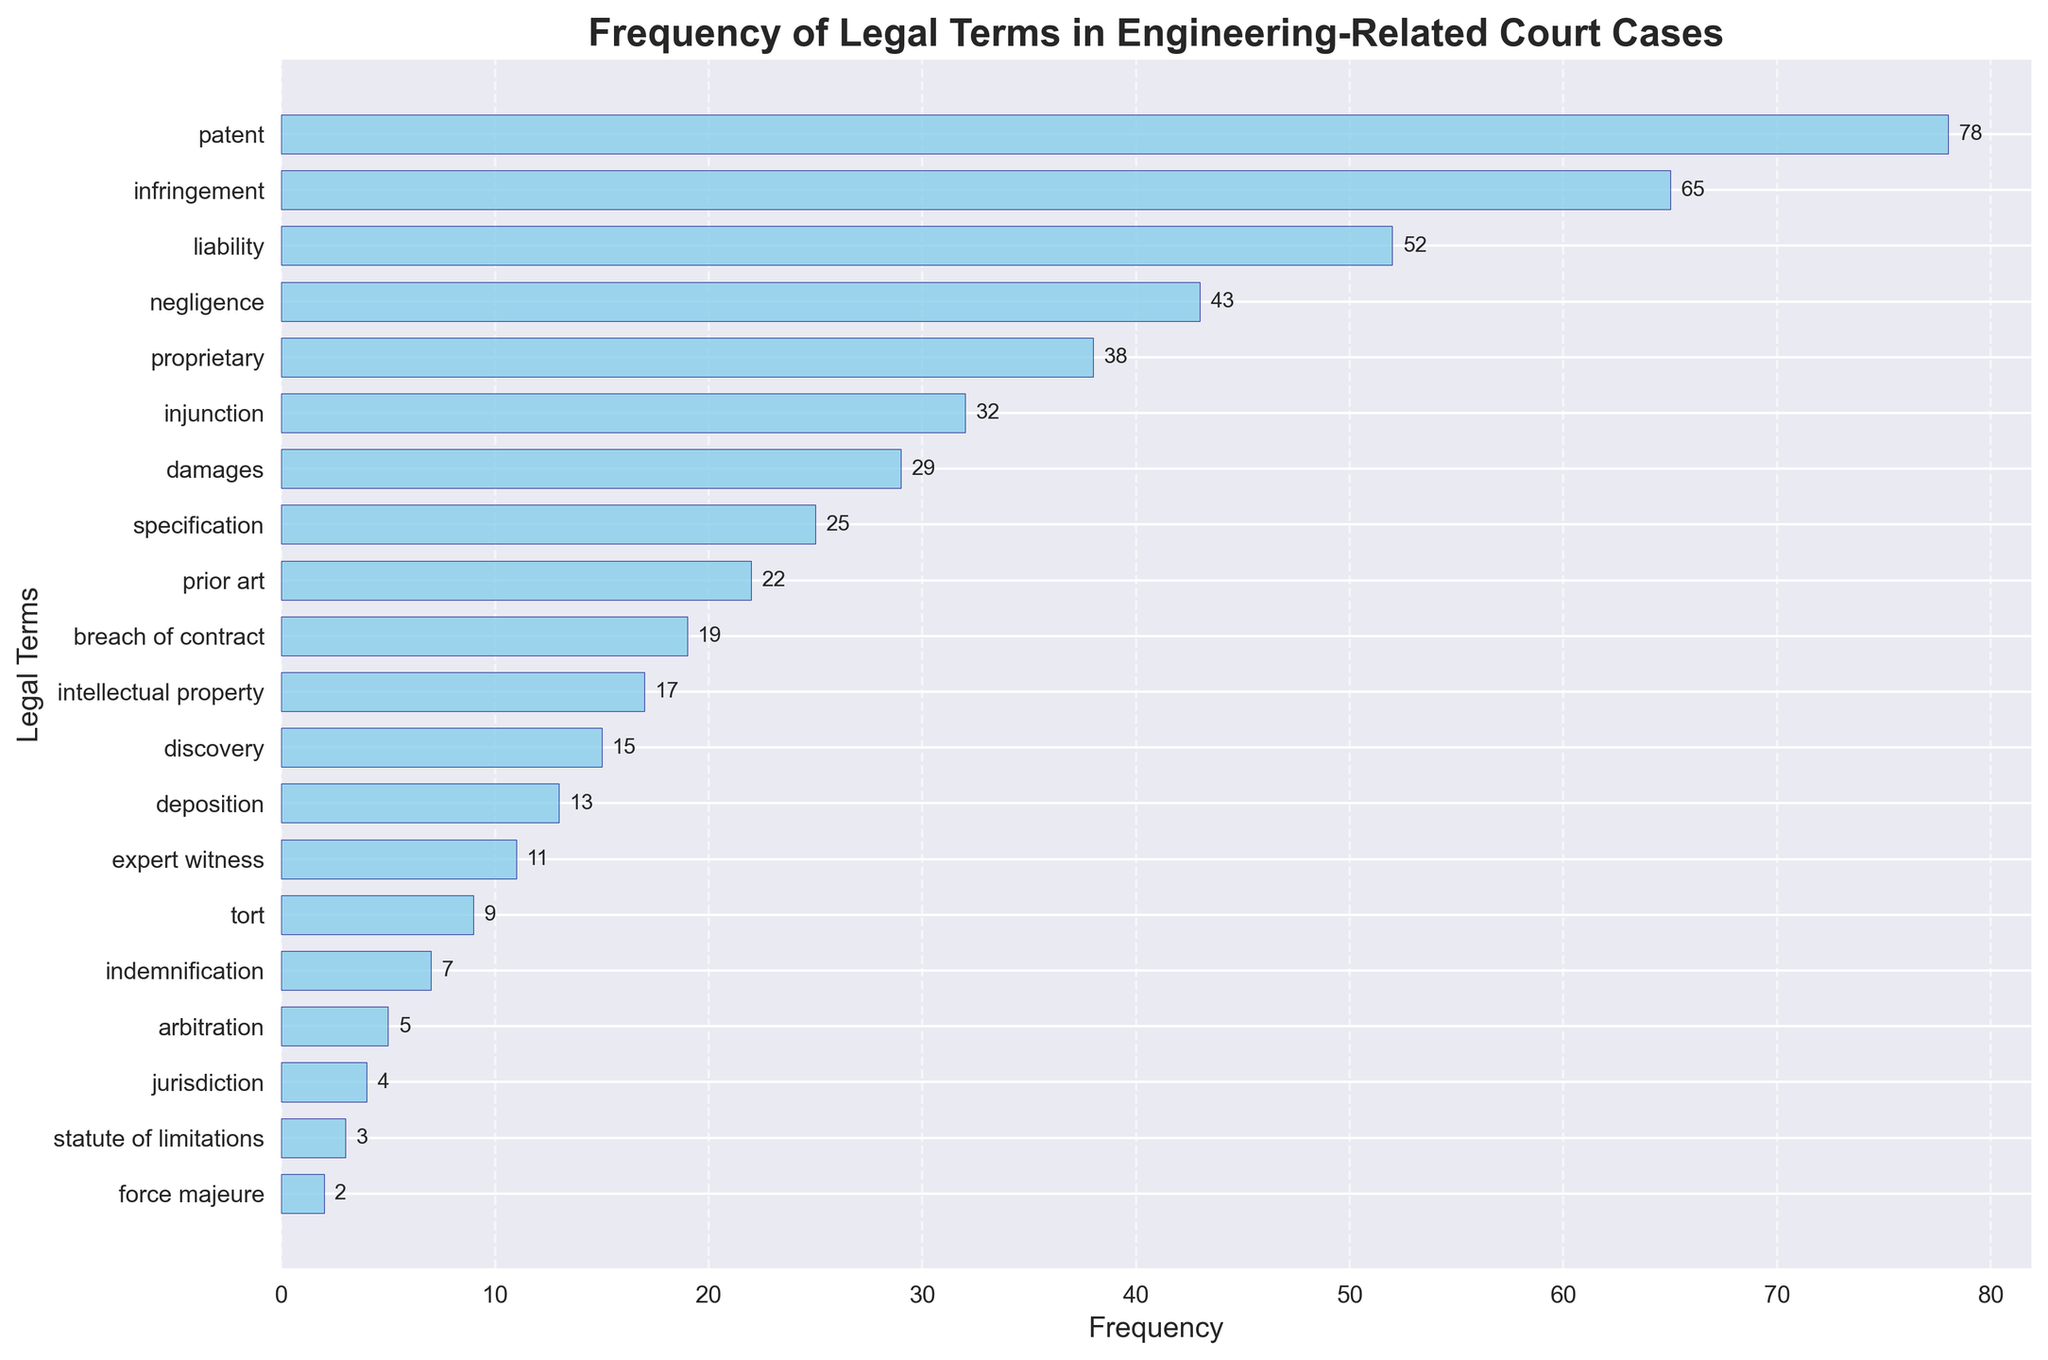What is the title of the plot? Look at the top of the figure where the title is located.
Answer: Frequency of Legal Terms in Engineering-Related Court Cases Which legal term has the highest frequency? Identify the longest bar in the horizontal density plot, then check the label next to it.
Answer: patent How many legal terms have a frequency greater than 20? Identify bars with lengths representing frequencies greater than 20 and count them.
Answer: 8 What is the combined frequency of the terms 'breach of contract' and 'intellectual property'? Look at the individual frequencies for 'breach of contract' and 'intellectual property', then add them together (19 + 17).
Answer: 36 Which legal term has the lowest frequency? Identify the shortest bar in the horizontal density plot, then check the label next to it.
Answer: force majeure How much more frequent is the term 'infringement' than 'negligence'? Find the frequencies of 'infringement' (65) and 'negligence' (43), then subtract the smaller from the larger (65 - 43).
Answer: 22 What is the average frequency of the terms listed in the plot? Sum all the frequency values and divide by the number of terms (20). Add frequencies (78 + 65 + 52 + 43 + 38 + 32 + 29 + 25 + 22 + 19 + 17 + 15 + 13 + 11 + 9 + 7 + 5 + 4 + 3 + 2 = 409). Then divide by 20 (409 / 20).
Answer: 20.45 What is the combined frequency of the three most common terms? Identify the frequencies for the three longest bars ('patent', 'infringement', 'liability'), then add them together (78 + 65 + 52).
Answer: 195 Which term has a frequency closer to 'injunction', 'specification' or 'damages'? Compare the values closest to 'injunction' (32). 'Specification' has a frequency of 25, and 'damages' has a frequency of 29.
Answer: damages How many terms have a frequency less than 10? Count the bars with lengths representing frequencies less than 10 and sum them up.
Answer: 4 